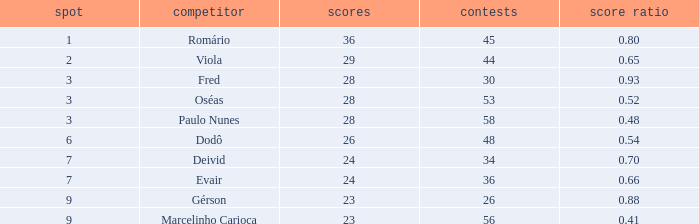What is the largest value for goals in rank over 3 with goal ration of 0.54? 26.0. 